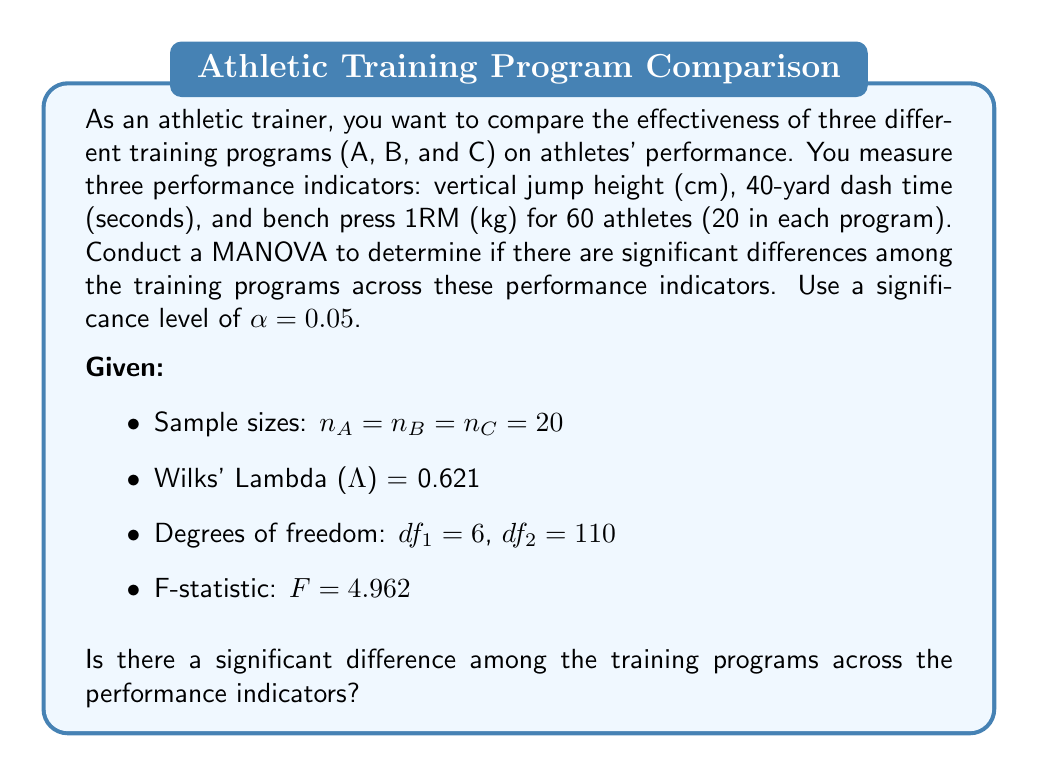Can you answer this question? To conduct a MANOVA and interpret the results, we'll follow these steps:

1. State the null and alternative hypotheses:
   $H_0$: There are no significant differences among the training programs across the performance indicators.
   $H_a$: There are significant differences among the training programs across the performance indicators.

2. Check the test statistic and its distribution:
   We're given Wilks' Lambda (Λ) = 0.621 and the F-statistic = 4.962.
   Wilks' Lambda is transformed into an F-statistic for hypothesis testing.

3. Determine the critical F-value:
   With $α = 0.05$, $df_1 = 6$, and $df_2 = 110$, we would typically look up the critical F-value in an F-distribution table. For this problem, let's assume the critical F-value is 2.18.

4. Compare the calculated F-statistic to the critical F-value:
   Calculated F-statistic: 4.962
   Critical F-value: 2.18

   Since 4.962 > 2.18, we reject the null hypothesis.

5. Calculate the p-value:
   The exact p-value calculation is complex, but we can determine that p < 0.05 because we rejected $H_0$ at α = 0.05.

6. Interpret the results:
   Rejecting the null hypothesis indicates that there are significant differences among the training programs across the performance indicators.

The low Wilks' Lambda (Λ = 0.621) suggests that a large proportion of the variance in the dependent variables (performance indicators) is accounted for by the independent variable (training program).
Answer: Yes, there is a significant difference among the training programs across the performance indicators (F = 4.962, p < 0.05, Wilks' Λ = 0.621). 